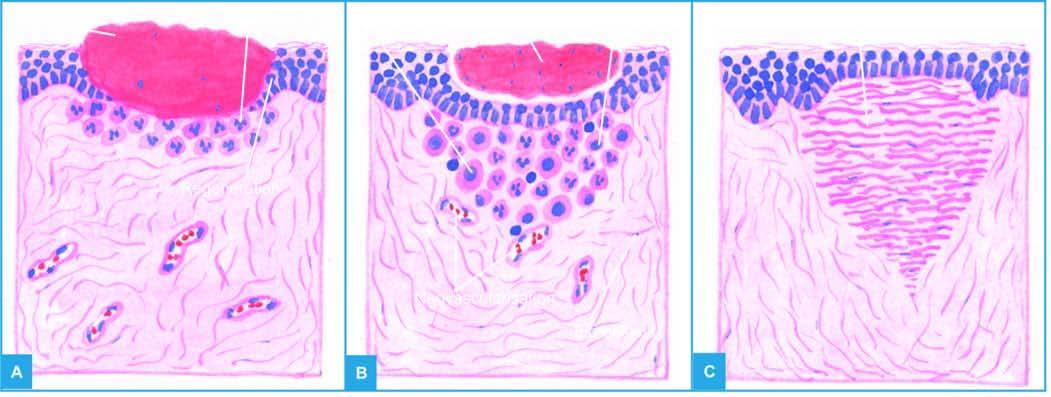what meet in the middle to cover the gap and separate the underlying viable tissue from necrotic tissue at the surface forming scab?
Answer the question using a single word or phrase. Epithelial spurs from the margins of wound 